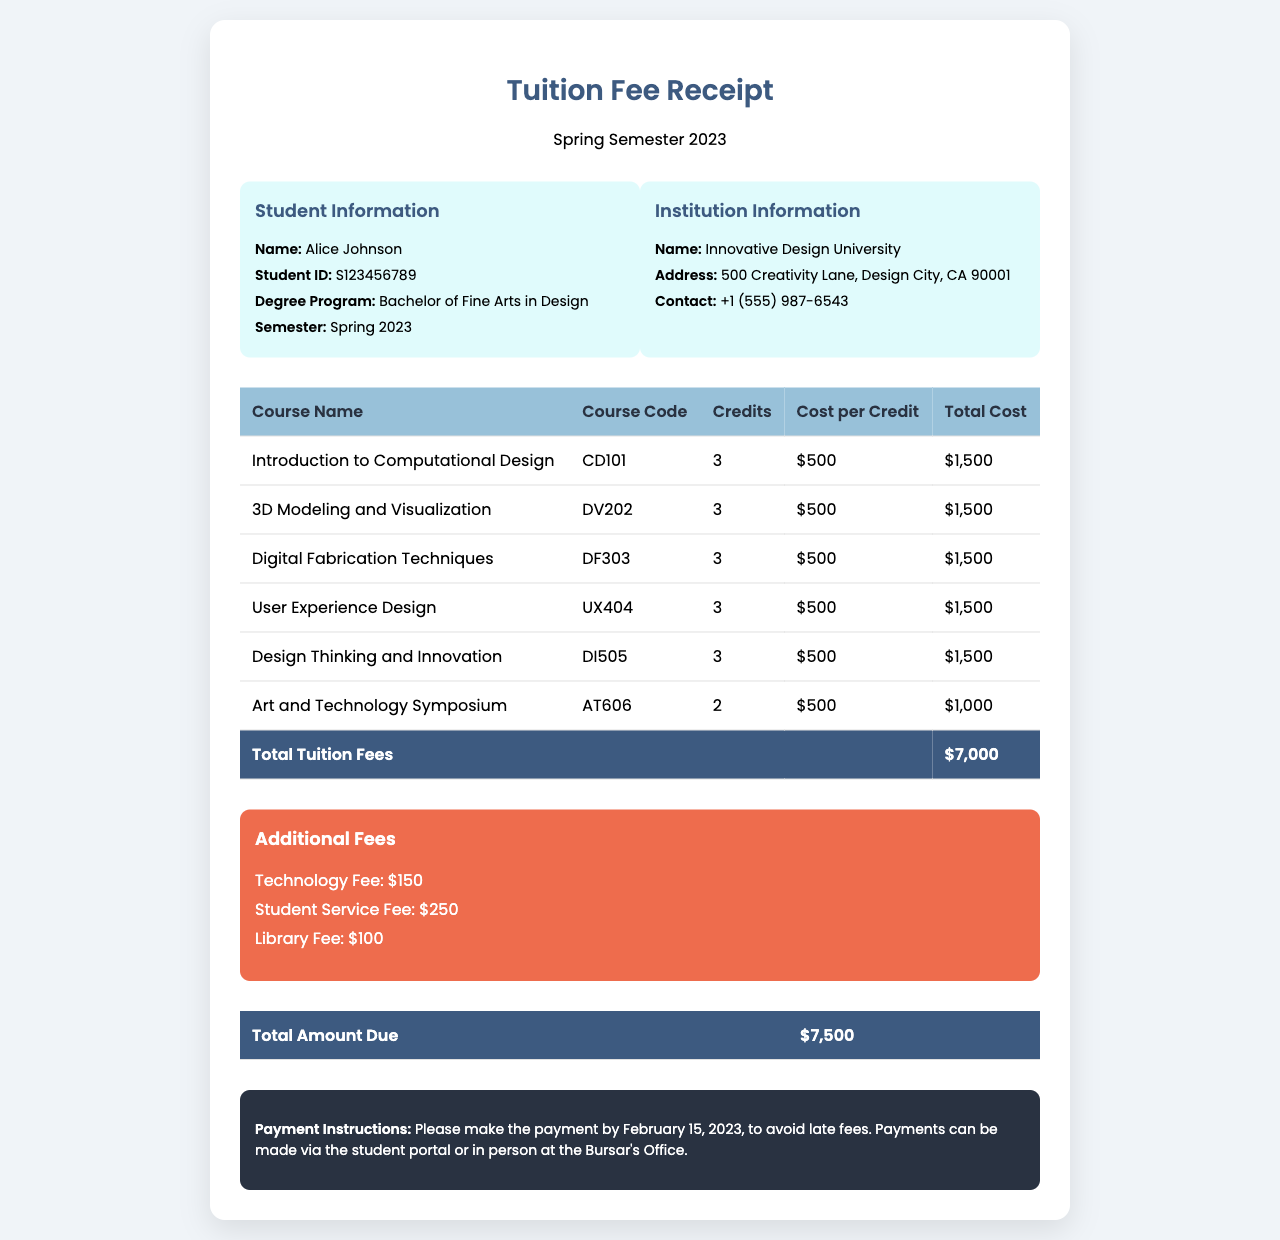What is the total tuition fee? The total tuition fee is the sum of all course costs as shown in the table, which is $7,000.
Answer: $7,000 Who is the student? The document provides information in the 'Student Information' section, which lists the name of the student as Alice Johnson.
Answer: Alice Johnson What are the additional fees listed? The additional fees can be found in the 'Additional Fees' section, which includes Technology Fee, Student Service Fee, and Library Fee.
Answer: Technology Fee, Student Service Fee, Library Fee What is the total amount due? The total amount due is mentioned in the last table section, calculated by adding tuition fees and additional fees, resulting in $7,500.
Answer: $7,500 What is the due date for the payment? The 'Payment Instructions' section specifies that the payment should be made by February 15, 2023.
Answer: February 15, 2023 How many credits is the course 'User Experience Design'? In the course breakdown, the credits for 'User Experience Design' are explicitly stated. It shows 3 credits.
Answer: 3 What is the cost per credit? The cost per credit is uniformly given for all courses in the table, which is stated as $500.
Answer: $500 What is the course code for 'Digital Fabrication Techniques'? The course code can be found in the course table next to 'Digital Fabrication Techniques,' which is DF303.
Answer: DF303 What is the name of the institution? The 'Institution Information' section provides the name of the institution, which is Innovative Design University.
Answer: Innovative Design University 